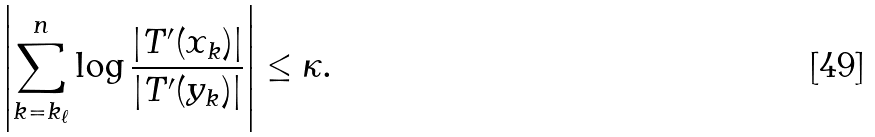Convert formula to latex. <formula><loc_0><loc_0><loc_500><loc_500>\left | \sum _ { k = k _ { \ell } } ^ { n } \log \frac { | T ^ { \prime } ( x _ { k } ) | } { | T ^ { \prime } ( y _ { k } ) | } \right | \leq \kappa .</formula> 